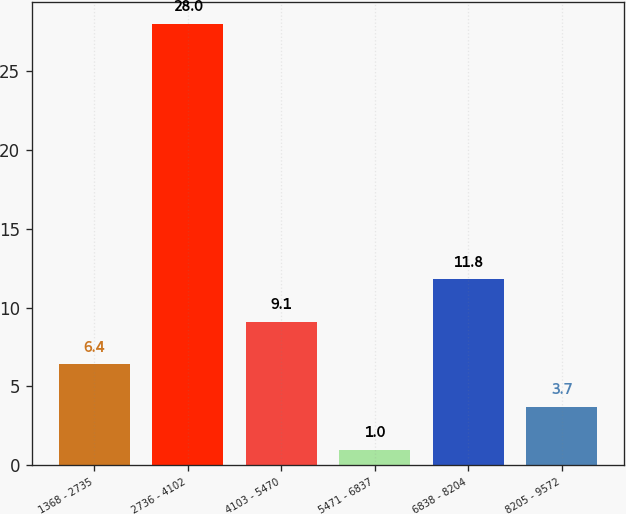Convert chart. <chart><loc_0><loc_0><loc_500><loc_500><bar_chart><fcel>1368 - 2735<fcel>2736 - 4102<fcel>4103 - 5470<fcel>5471 - 6837<fcel>6838 - 8204<fcel>8205 - 9572<nl><fcel>6.4<fcel>28<fcel>9.1<fcel>1<fcel>11.8<fcel>3.7<nl></chart> 